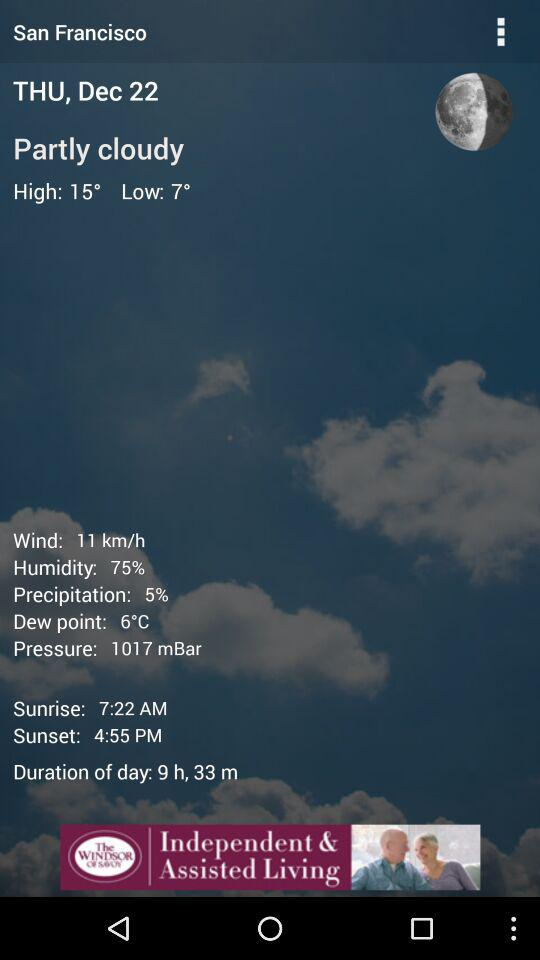What is the sunrise time? The sunrise time is 7:22 AM. 